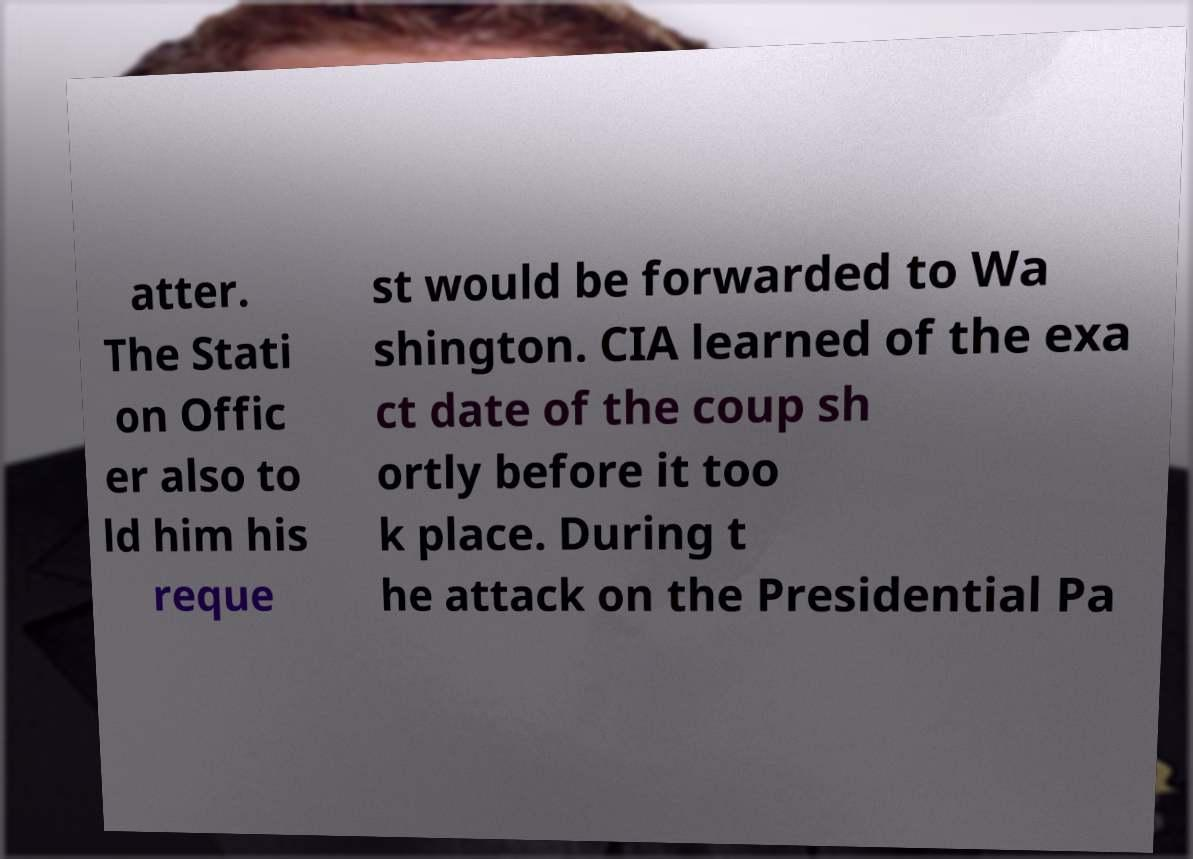There's text embedded in this image that I need extracted. Can you transcribe it verbatim? atter. The Stati on Offic er also to ld him his reque st would be forwarded to Wa shington. CIA learned of the exa ct date of the coup sh ortly before it too k place. During t he attack on the Presidential Pa 